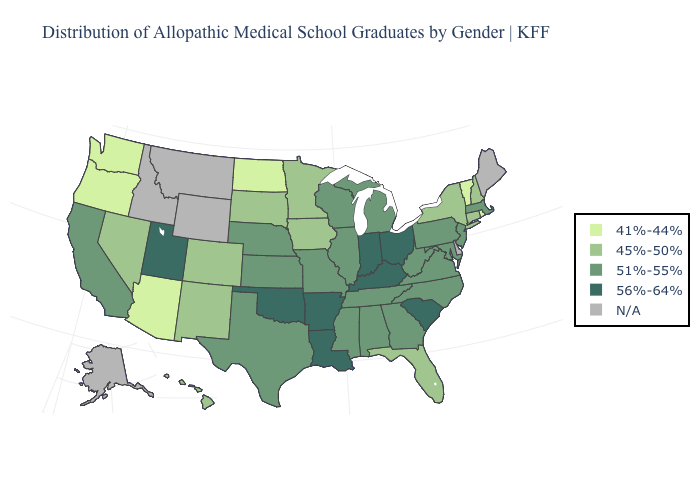Among the states that border North Dakota , which have the highest value?
Concise answer only. Minnesota, South Dakota. What is the highest value in the USA?
Keep it brief. 56%-64%. What is the value of Maryland?
Be succinct. 51%-55%. Which states have the lowest value in the South?
Short answer required. Florida. Does Ohio have the highest value in the MidWest?
Give a very brief answer. Yes. What is the lowest value in the Northeast?
Quick response, please. 41%-44%. What is the lowest value in states that border Texas?
Give a very brief answer. 45%-50%. Name the states that have a value in the range 51%-55%?
Answer briefly. Alabama, California, Georgia, Illinois, Kansas, Maryland, Massachusetts, Michigan, Mississippi, Missouri, Nebraska, New Jersey, North Carolina, Pennsylvania, Tennessee, Texas, Virginia, West Virginia, Wisconsin. What is the value of Maine?
Keep it brief. N/A. Name the states that have a value in the range 41%-44%?
Write a very short answer. Arizona, North Dakota, Oregon, Rhode Island, Vermont, Washington. What is the value of Idaho?
Concise answer only. N/A. 